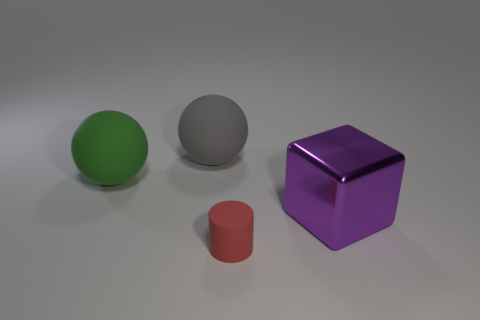Are there any other things that have the same material as the big purple thing?
Your response must be concise. No. The red object that is made of the same material as the big green sphere is what shape?
Your answer should be very brief. Cylinder. There is a thing that is in front of the large purple thing; does it have the same shape as the green rubber thing?
Ensure brevity in your answer.  No. There is a rubber object that is in front of the object left of the large gray rubber thing; how big is it?
Make the answer very short. Small. There is another sphere that is made of the same material as the large green ball; what is its color?
Provide a short and direct response. Gray. What number of other metallic things have the same size as the metal object?
Ensure brevity in your answer.  0. How many red things are either big things or metal cubes?
Give a very brief answer. 0. What number of objects are green things or objects that are on the left side of the purple metallic thing?
Keep it short and to the point. 3. What is the material of the large object that is to the left of the gray matte ball?
Your response must be concise. Rubber. There is a green matte object that is the same size as the metallic block; what is its shape?
Your response must be concise. Sphere. 